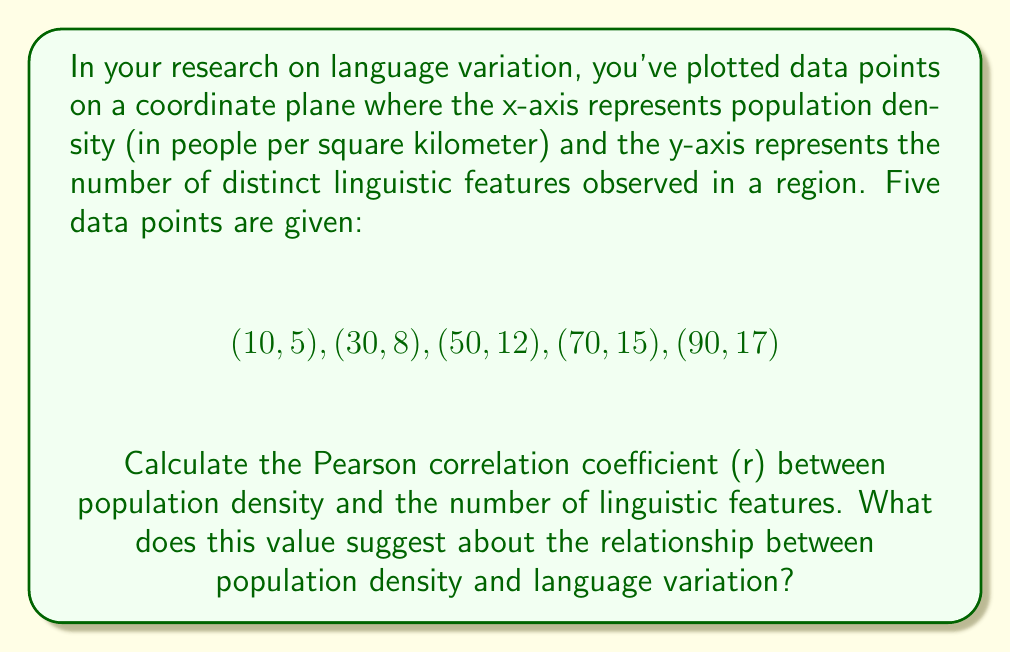Can you solve this math problem? To calculate the Pearson correlation coefficient (r), we'll follow these steps:

1) First, let's calculate the means of x (population density) and y (linguistic features):

   $\bar{x} = \frac{10 + 30 + 50 + 70 + 90}{5} = 50$
   $\bar{y} = \frac{5 + 8 + 12 + 15 + 17}{5} = 11.4$

2) Now, we'll calculate the necessary sums for the correlation formula:

   $\sum (x - \bar{x})(y - \bar{y})$
   $\sum (x - \bar{x})^2$
   $\sum (y - \bar{y})^2$

3) Let's compute these values:

   $\sum (x - \bar{x})(y - \bar{y}) = (-40)(-6.4) + (-20)(-3.4) + (0)(0.6) + (20)(3.6) + (40)(5.6) = 256 + 68 + 0 + 72 + 224 = 620$

   $\sum (x - \bar{x})^2 = (-40)^2 + (-20)^2 + (0)^2 + (20)^2 + (40)^2 = 1600 + 400 + 0 + 400 + 1600 = 4000$

   $\sum (y - \bar{y})^2 = (-6.4)^2 + (-3.4)^2 + (0.6)^2 + (3.6)^2 + (5.6)^2 = 40.96 + 11.56 + 0.36 + 12.96 + 31.36 = 97.2$

4) Now we can apply the formula for the Pearson correlation coefficient:

   $$r = \frac{\sum (x - \bar{x})(y - \bar{y})}{\sqrt{\sum (x - \bar{x})^2 \sum (y - \bar{y})^2}}$$

   $$r = \frac{620}{\sqrt{4000 \times 97.2}} = \frac{620}{\sqrt{388800}} = \frac{620}{623.54} \approx 0.9943$$

5) Interpretation: The correlation coefficient r ≈ 0.9943 indicates a very strong positive correlation between population density and the number of linguistic features. This suggests that as population density increases, the number of distinct linguistic features also tends to increase, almost in a linear fashion.
Answer: The Pearson correlation coefficient is approximately 0.9943, indicating a very strong positive correlation between population density and the number of linguistic features observed. 